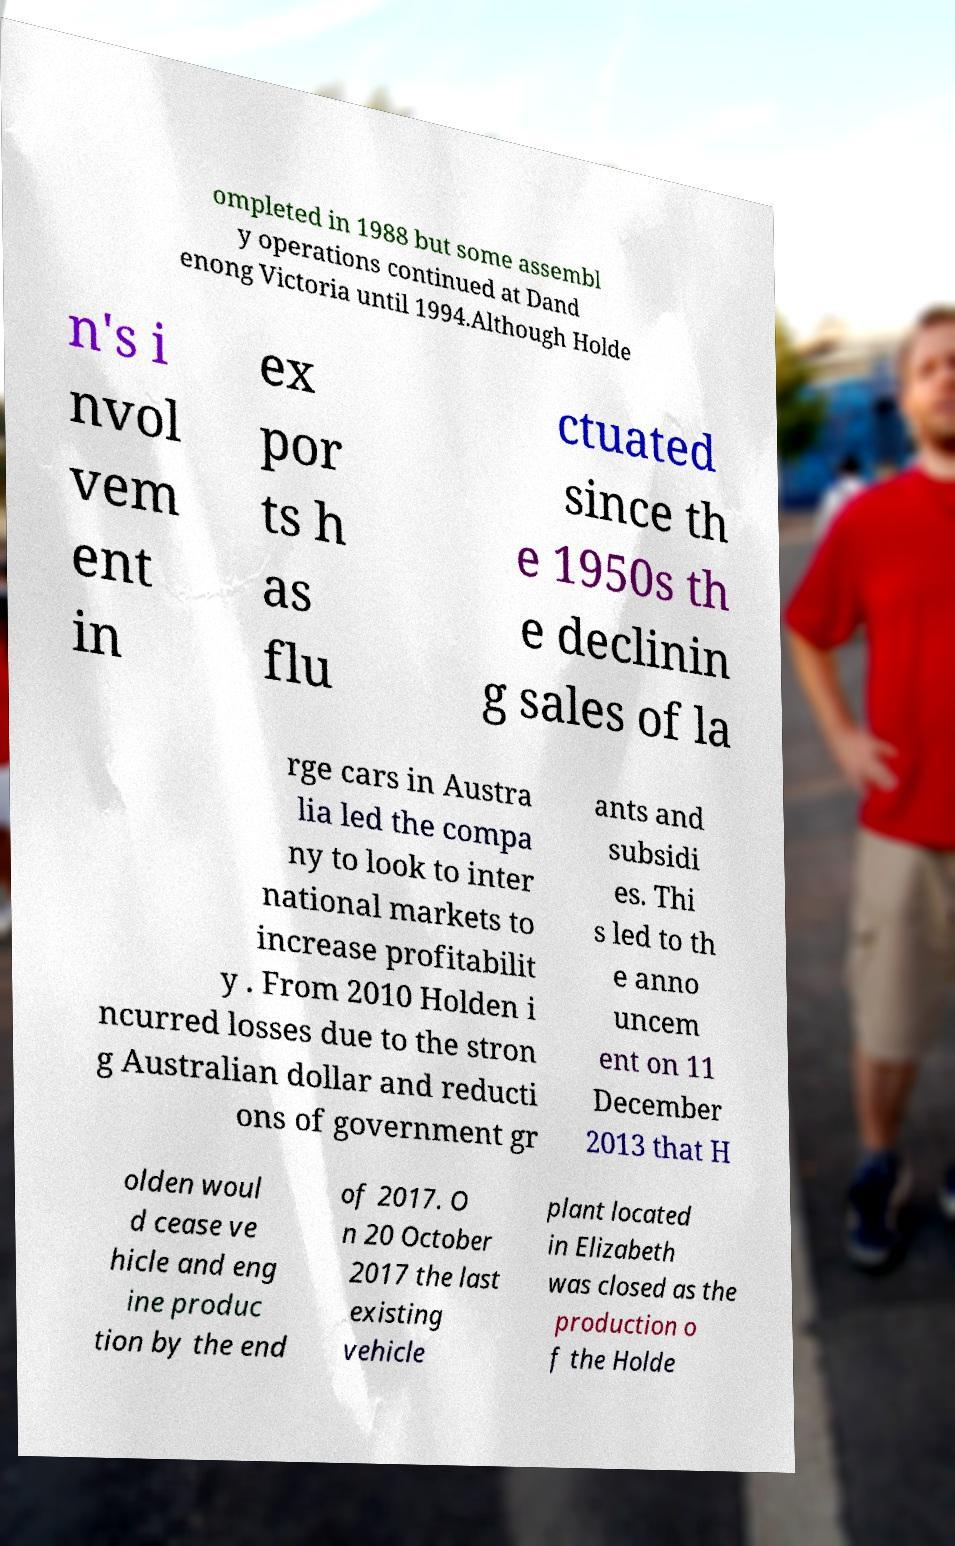I need the written content from this picture converted into text. Can you do that? ompleted in 1988 but some assembl y operations continued at Dand enong Victoria until 1994.Although Holde n's i nvol vem ent in ex por ts h as flu ctuated since th e 1950s th e declinin g sales of la rge cars in Austra lia led the compa ny to look to inter national markets to increase profitabilit y . From 2010 Holden i ncurred losses due to the stron g Australian dollar and reducti ons of government gr ants and subsidi es. Thi s led to th e anno uncem ent on 11 December 2013 that H olden woul d cease ve hicle and eng ine produc tion by the end of 2017. O n 20 October 2017 the last existing vehicle plant located in Elizabeth was closed as the production o f the Holde 